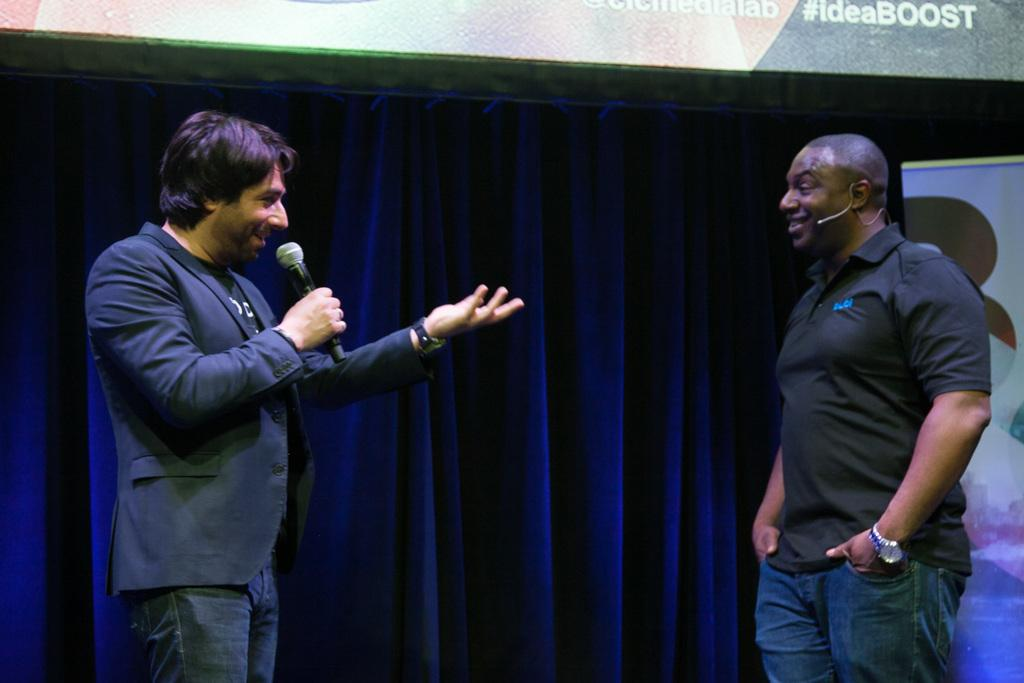How many people are in the image? There are two persons standing in the image. What is one of the persons holding? One person is holding a microphone. What can be seen in the background of the image? There is a curtain and a banner in the background of the image. What type of yak is visible in the image? There is no yak present in the image. What pet is being held by one of the persons in the image? There is no pet visible in the image. 